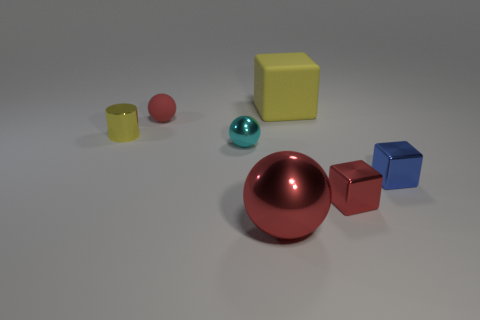Are there an equal number of large yellow rubber cubes that are left of the rubber ball and large gray cylinders?
Give a very brief answer. Yes. There is a cyan sphere behind the blue thing; are there any small balls on the left side of it?
Your answer should be compact. Yes. There is a object on the left side of the red object that is on the left side of the red sphere that is in front of the tiny blue shiny thing; what size is it?
Make the answer very short. Small. What is the material of the yellow object on the left side of the matte thing that is to the right of the small red rubber sphere?
Keep it short and to the point. Metal. Are there any other big rubber objects that have the same shape as the yellow rubber object?
Give a very brief answer. No. The yellow shiny object is what shape?
Offer a terse response. Cylinder. What is the material of the large thing in front of the small shiny block that is right of the small thing that is in front of the blue thing?
Give a very brief answer. Metal. Are there more big yellow cubes that are on the right side of the yellow rubber block than tiny cyan metal balls?
Offer a very short reply. No. What is the material of the blue cube that is the same size as the red matte sphere?
Provide a short and direct response. Metal. Are there any yellow things that have the same size as the yellow cylinder?
Provide a succinct answer. No. 